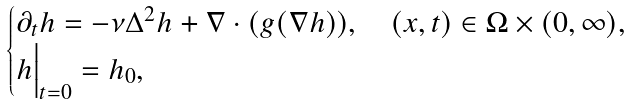<formula> <loc_0><loc_0><loc_500><loc_500>\begin{cases} \partial _ { t } h = - \nu \Delta ^ { 2 } h + \nabla \cdot ( g ( \nabla h ) ) , \quad ( x , t ) \in \Omega \times ( 0 , \infty ) , \\ h \Big | _ { t = 0 } = h _ { 0 } , \end{cases}</formula> 